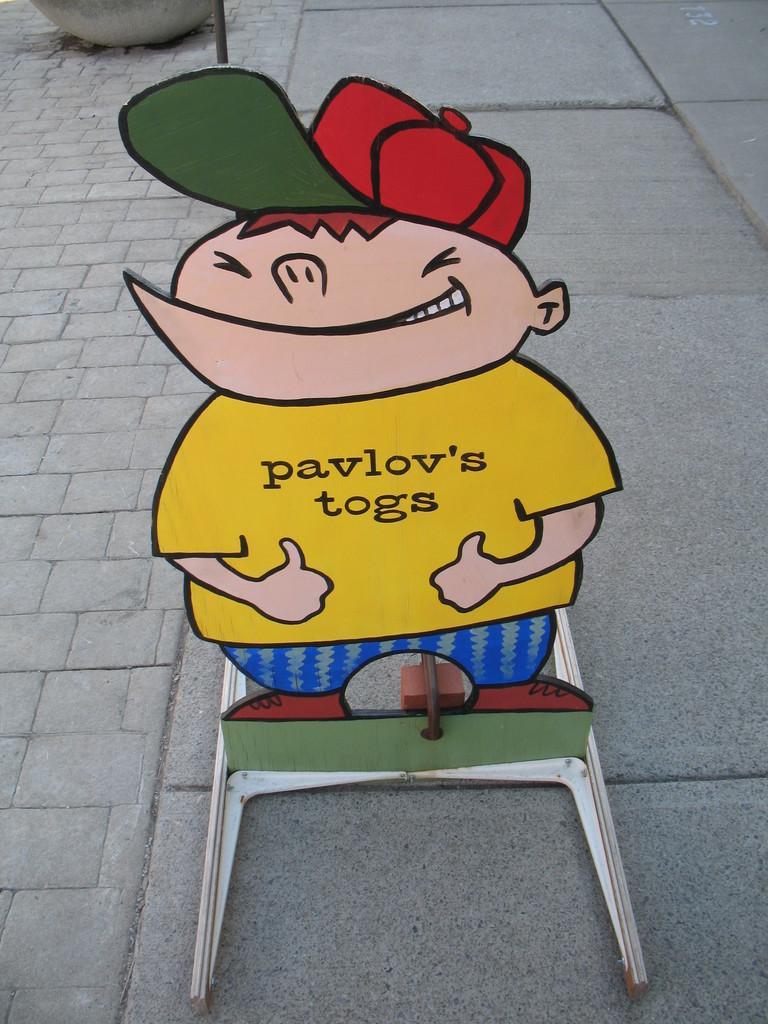In one or two sentences, can you explain what this image depicts? In the image in the center we can see one cartoon stand. In the background there is a pot and road. 